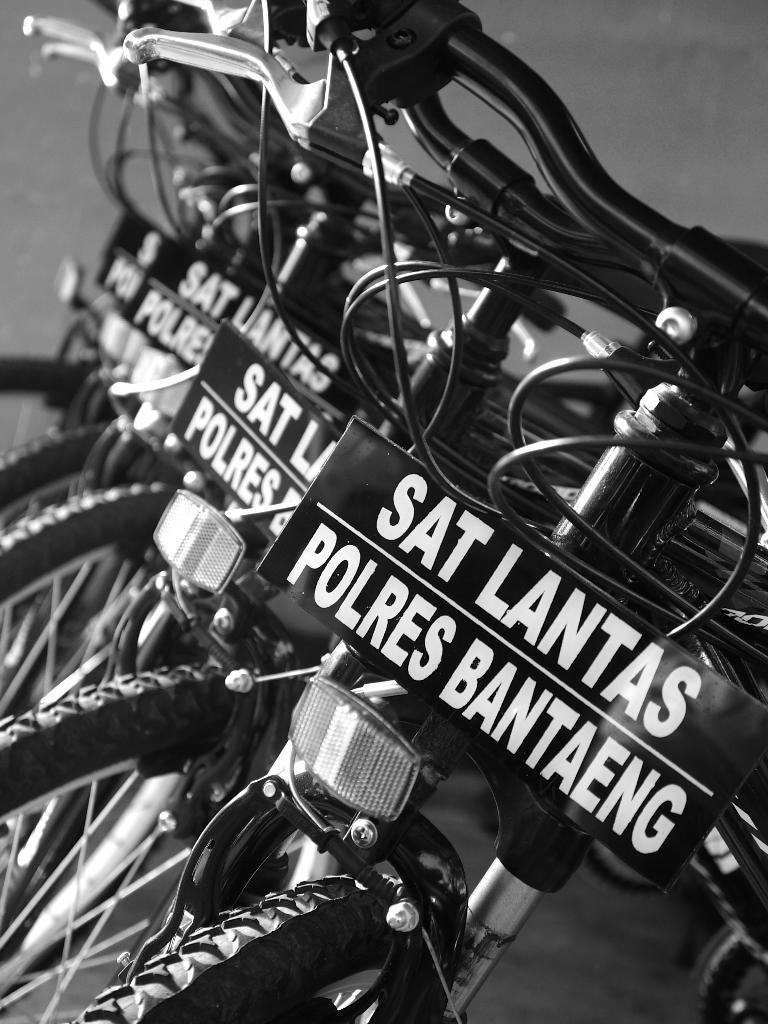What type of vehicles are in the image? There are bicycles in the image. What is the status of the bicycles in the image? The bicycles are parked. Are there any additional features on the bicycles? Yes, there is a board is attached to at least one of the bicycles. What can be seen on the board? The board has text on it. What type of flesh can be seen on the bicycles in the image? There is no flesh present on the bicycles in the image; they are inanimate objects. 